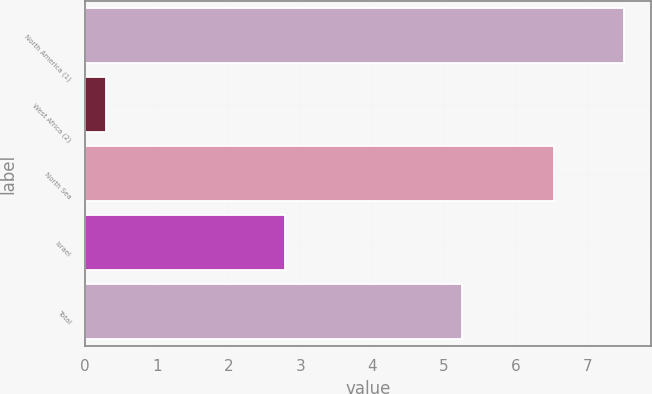Convert chart. <chart><loc_0><loc_0><loc_500><loc_500><bar_chart><fcel>North America (1)<fcel>West Africa (2)<fcel>North Sea<fcel>Israel<fcel>Total<nl><fcel>7.51<fcel>0.29<fcel>6.54<fcel>2.79<fcel>5.26<nl></chart> 